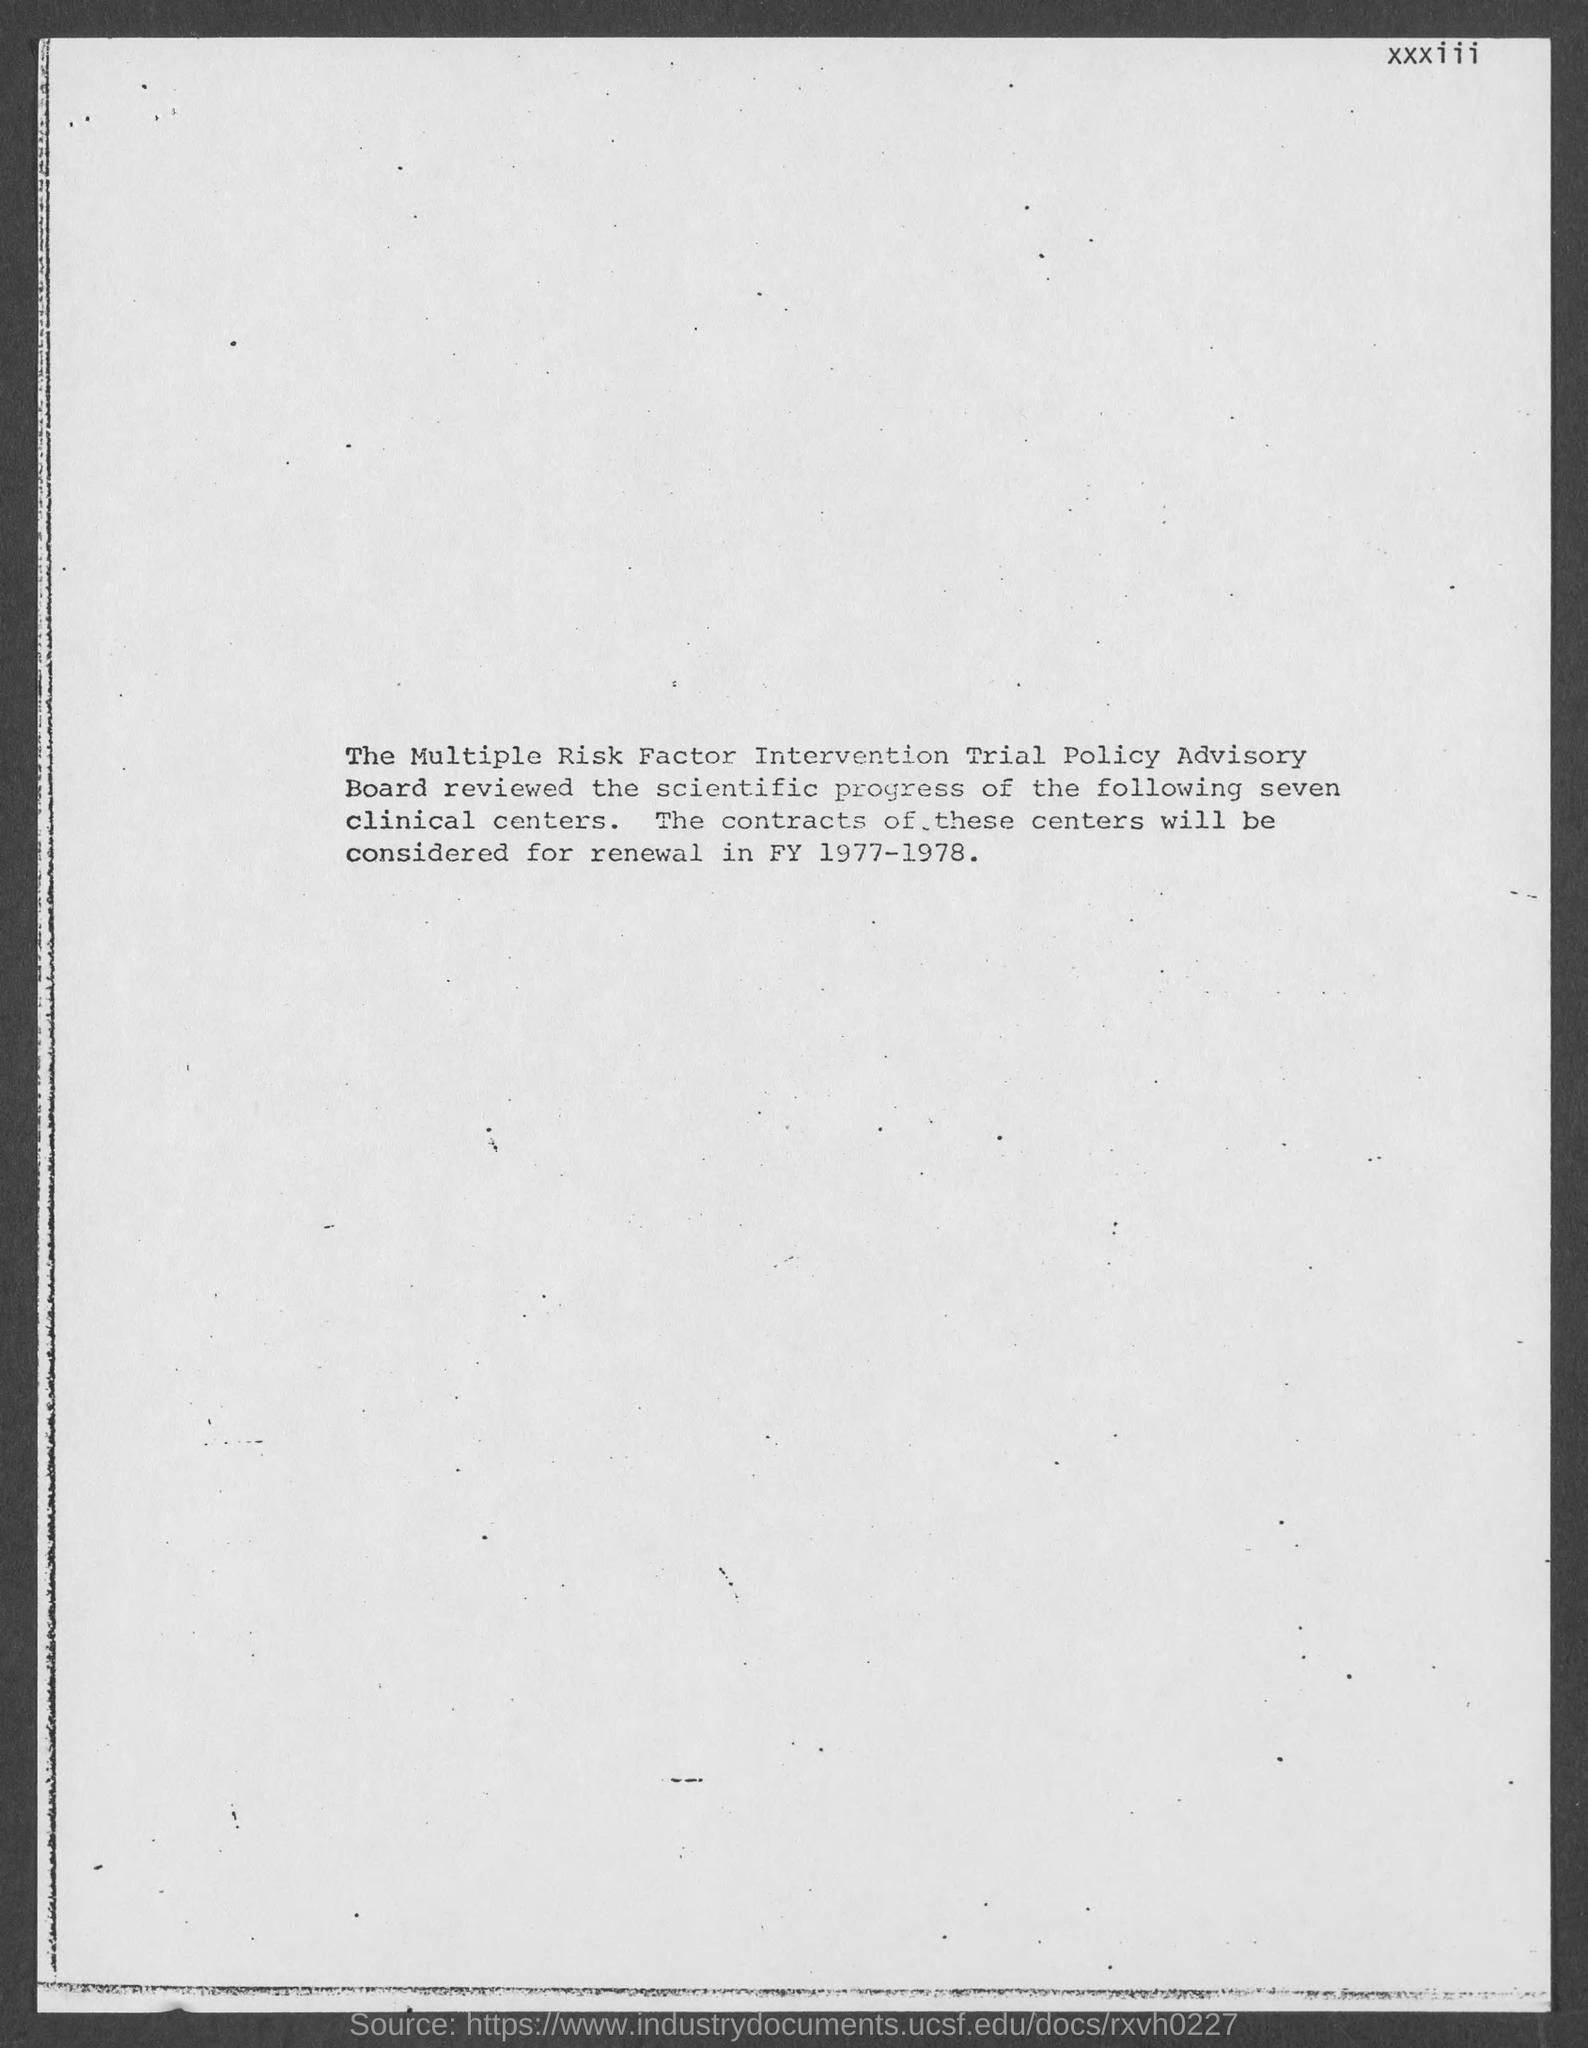In which year will the contracts of these centers be considered for renewal ?
Provide a short and direct response. FY 1977-1978. 